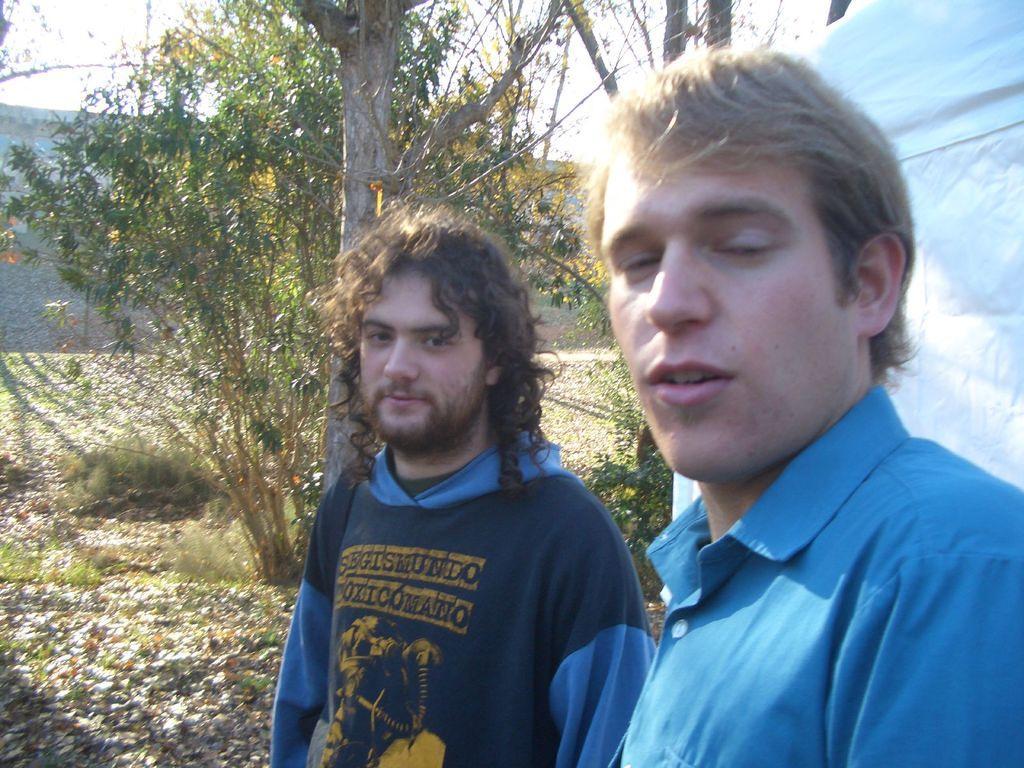Could you give a brief overview of what you see in this image? In this image there are two men in the middle. In the background there are trees. On the ground there are leaves. On the right side there is a white cloth. 